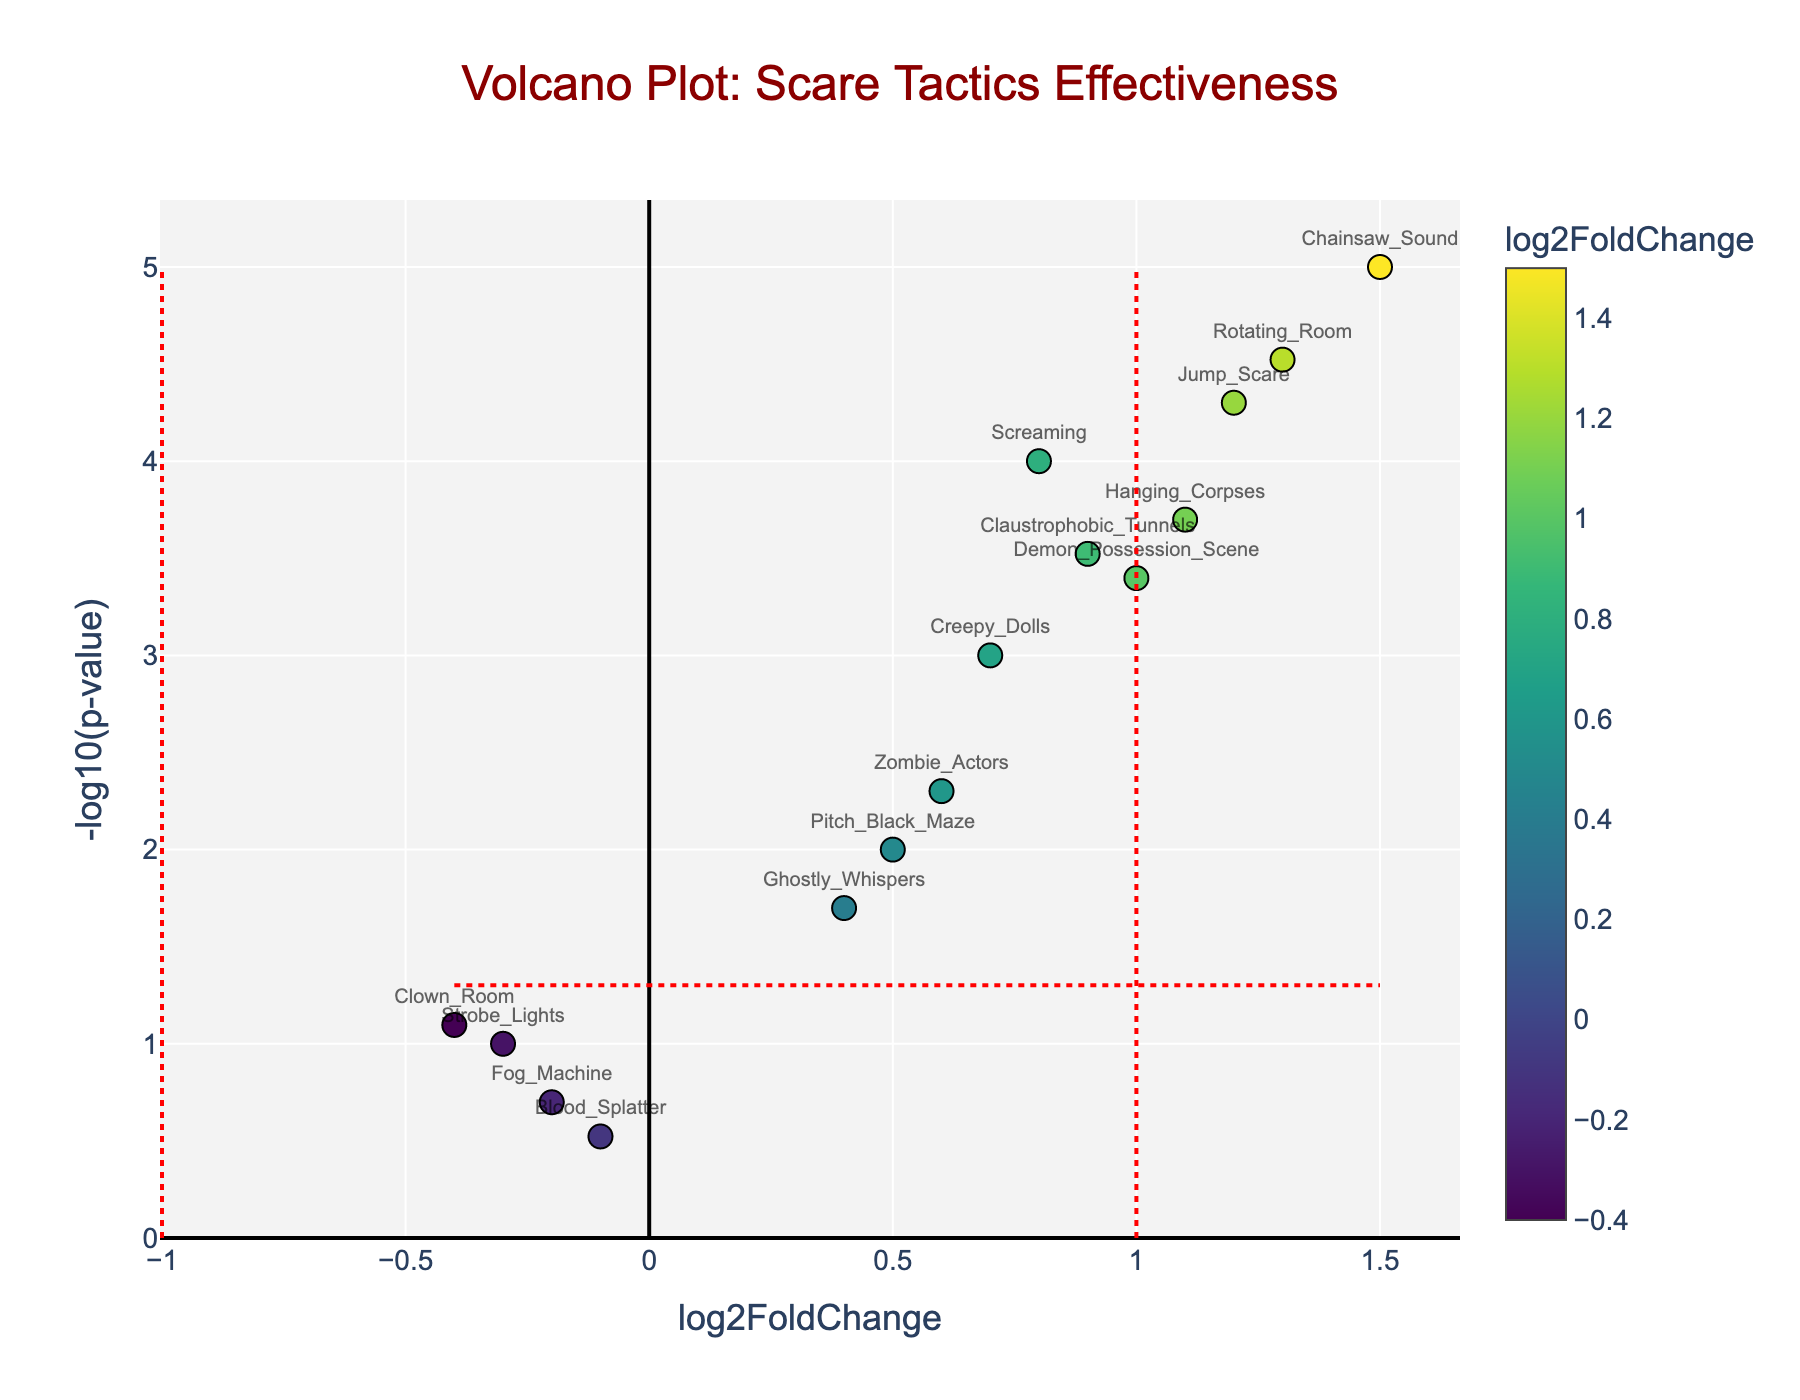What is the title of the plot? The title of the plot is prominently displayed at the top of the figure and provides an overview of what the plot represents.
Answer: Volcano Plot: Scare Tactics Effectiveness What is shown on the x-axis? The x-axis of the plot typically represents the log2FoldChange in a Volcano Plot, which indicates the fold change in heart rate and cortisol levels before and after experiencing different scare tactics.
Answer: log2FoldChange Which scare tactic has the lowest p-value? The scare tactic with the lowest p-value will have the highest -log10(p-value) value, as this value is the negative logarithm of the p-value.
Answer: Chainsaw Sound How many scare tactics have a log2FoldChange greater than 1? Count the data points to the right of the vertical red dashed line at log2FoldChange=1. Each point represents a scare tactic.
Answer: 4 Which scare tactic has the most significant increase in effectiveness? The scare tactic with the highest log2FoldChange value represents the most significant increase in effectiveness.
Answer: Chainsaw Sound Are there any scare tactics that show a decrease in effectiveness? Look for data points with negative log2FoldChange values; these points represent scare tactics that show a decrease in effectiveness.
Answer: Yes, Strobe Lights, Blood Splatter, Fog Machine, Clown Room Which scare tactic has a log2FoldChange closest to zero but is still significant? Identify the data point closest to zero on the x-axis but above the horizontal red dashed line indicating the significance threshold of -log10(p-value) = 1.3.
Answer: Ghostly Whispers How many scare tactics are statistically significant (p-value < 0.05)? Count the number of data points above the horizontal red dashed line indicating the significance threshold.
Answer: 10 What is the range of log2FoldChange values for all scare tactics? Determine the minimum and maximum values on the x-axis to find the range of log2FoldChange values.
Answer: From −0.4 to 1.5 Which scare tactic has a log2FoldChange of about 1 and a significant p-value? Identify the data points around the log2FoldChange=1 mark and check if they are above the horizontal significance threshold.
Answer: Hanging Corpses 